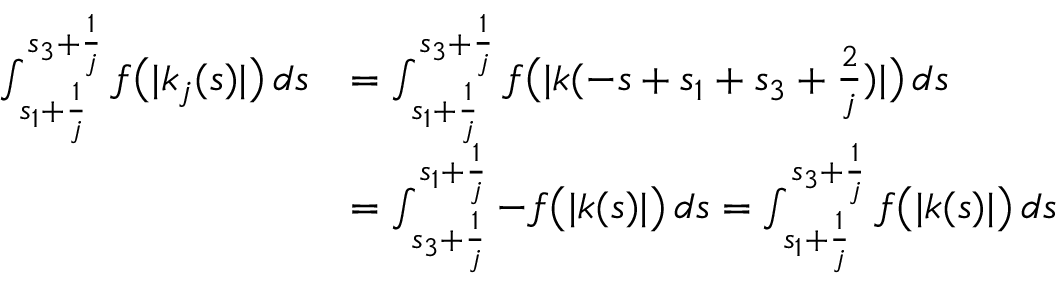Convert formula to latex. <formula><loc_0><loc_0><loc_500><loc_500>\begin{array} { r l } { \int _ { s _ { 1 } + \frac { 1 } { j } } ^ { s _ { 3 } + \frac { 1 } { j } } f \left ( | k _ { j } ( s ) | \right ) \, d s } & { = \int _ { s _ { 1 } + \frac { 1 } { j } } ^ { s _ { 3 } + \frac { 1 } { j } } f \left ( | k ( - s + s _ { 1 } + s _ { 3 } + \frac { 2 } { j } ) | \right ) \, d s } \\ & { = \int _ { s _ { 3 } + \frac { 1 } { j } } ^ { s _ { 1 } + \frac { 1 } { j } } - f \left ( | k ( s ) | \right ) \, d s = \int _ { s _ { 1 } + \frac { 1 } { j } } ^ { s _ { 3 } + \frac { 1 } { j } } f \left ( | k ( s ) | \right ) \, d s } \end{array}</formula> 